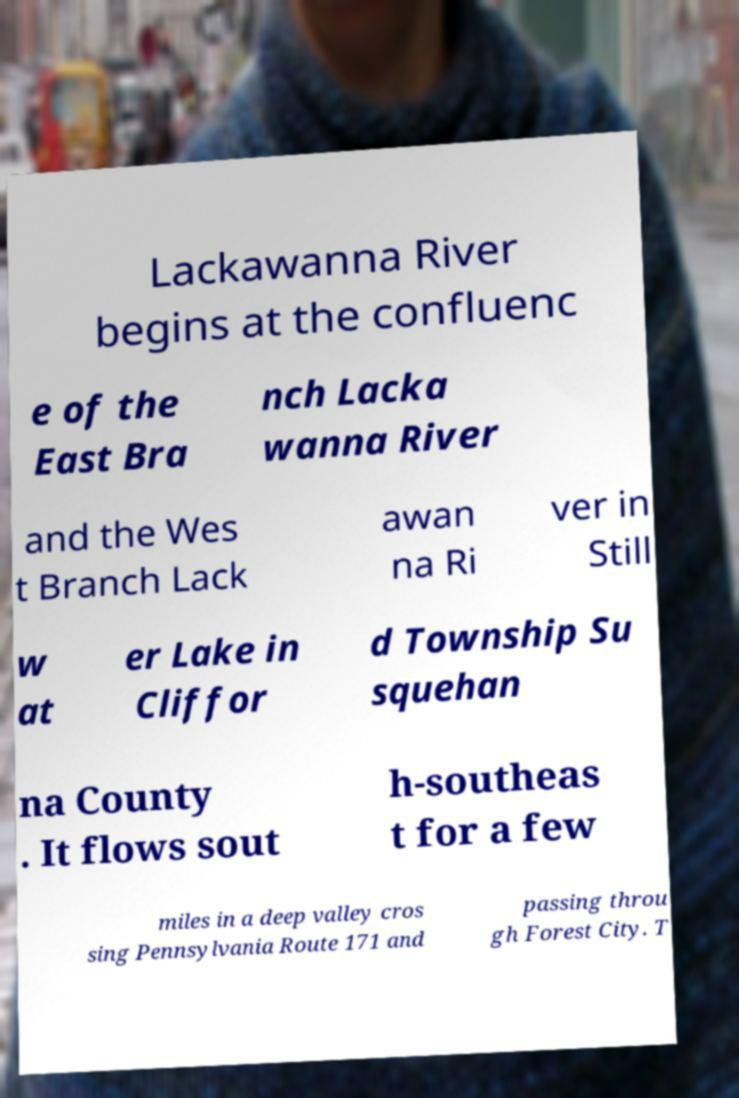Could you extract and type out the text from this image? Lackawanna River begins at the confluenc e of the East Bra nch Lacka wanna River and the Wes t Branch Lack awan na Ri ver in Still w at er Lake in Cliffor d Township Su squehan na County . It flows sout h-southeas t for a few miles in a deep valley cros sing Pennsylvania Route 171 and passing throu gh Forest City. T 